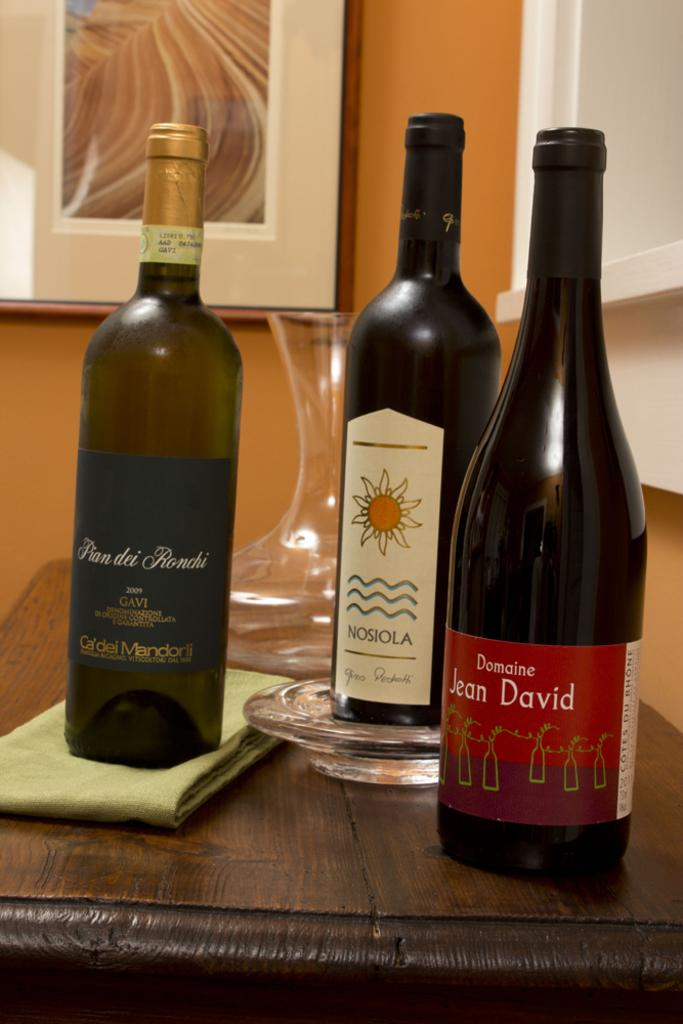<image>
Offer a succinct explanation of the picture presented. Three glass bottles of wine and one from Jean David. 